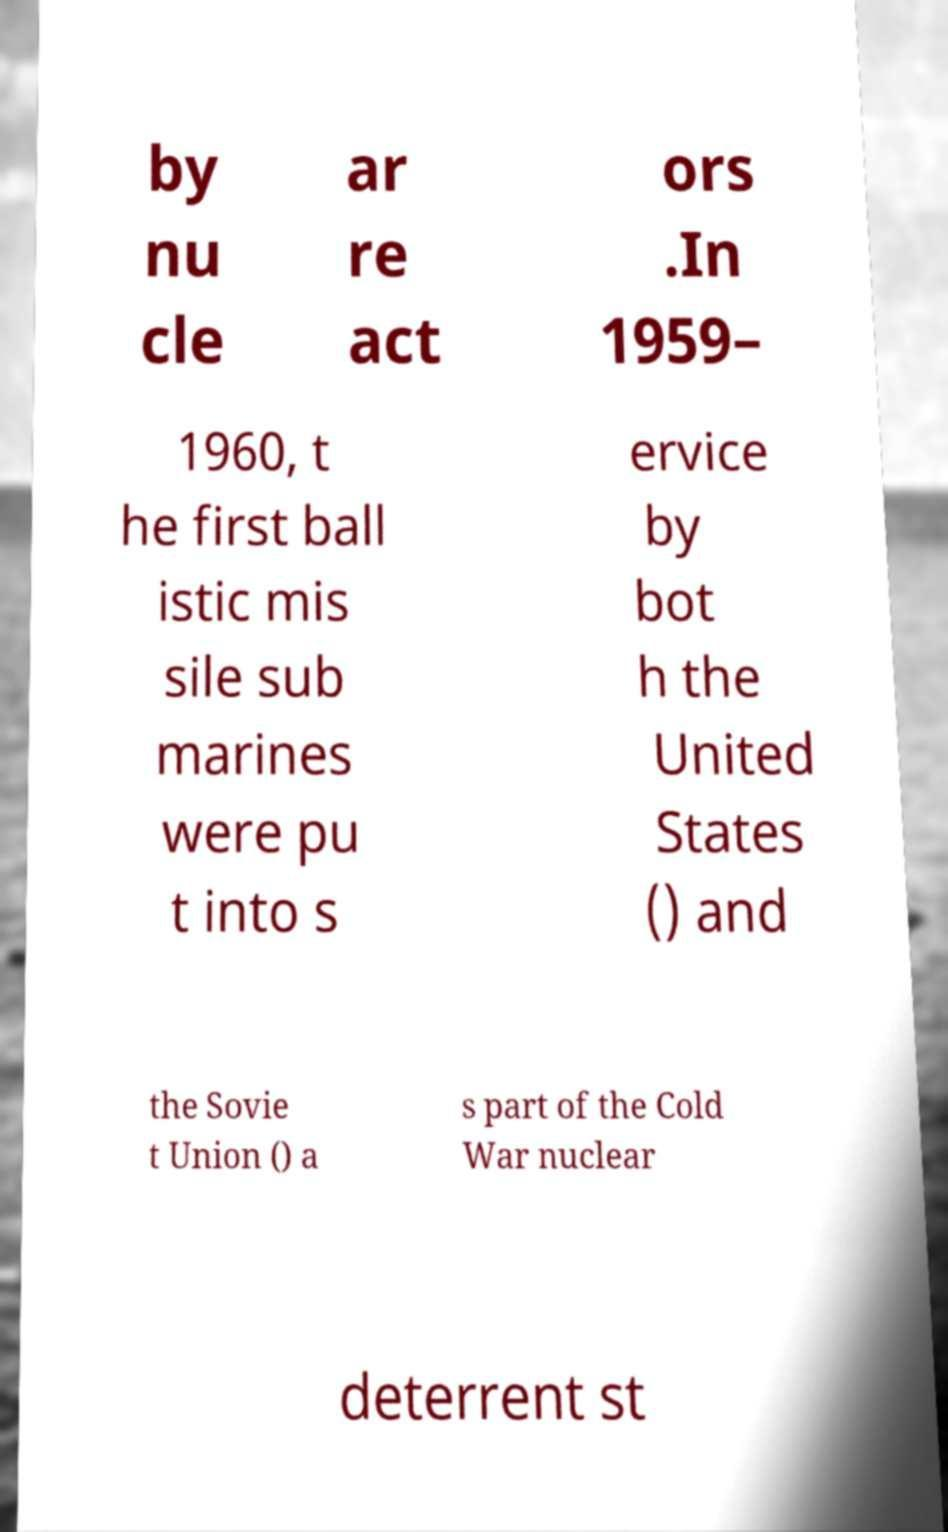For documentation purposes, I need the text within this image transcribed. Could you provide that? by nu cle ar re act ors .In 1959– 1960, t he first ball istic mis sile sub marines were pu t into s ervice by bot h the United States () and the Sovie t Union () a s part of the Cold War nuclear deterrent st 